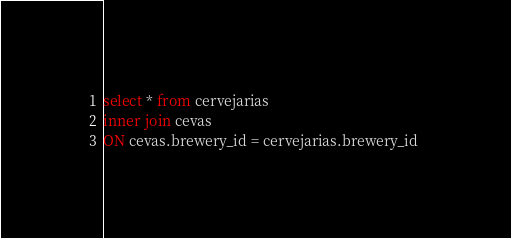Convert code to text. <code><loc_0><loc_0><loc_500><loc_500><_SQL_>select * from cervejarias
inner join cevas
ON cevas.brewery_id = cervejarias.brewery_id </code> 